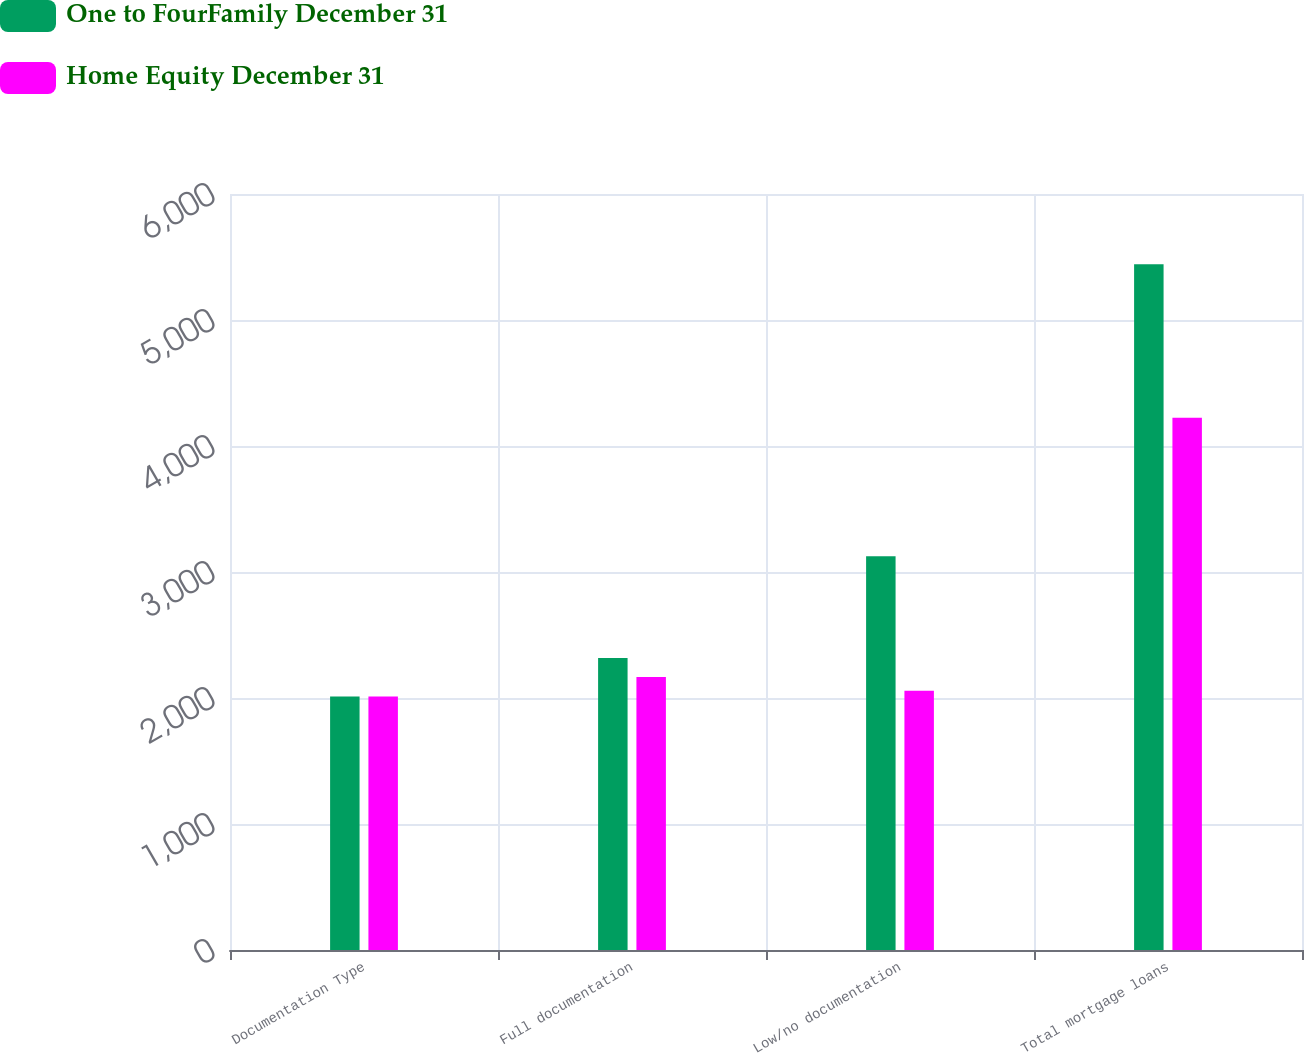Convert chart to OTSL. <chart><loc_0><loc_0><loc_500><loc_500><stacked_bar_chart><ecel><fcel>Documentation Type<fcel>Full documentation<fcel>Low/no documentation<fcel>Total mortgage loans<nl><fcel>One to FourFamily December 31<fcel>2012<fcel>2317.9<fcel>3124.3<fcel>5442.2<nl><fcel>Home Equity December 31<fcel>2012<fcel>2166.5<fcel>2056.9<fcel>4223.4<nl></chart> 